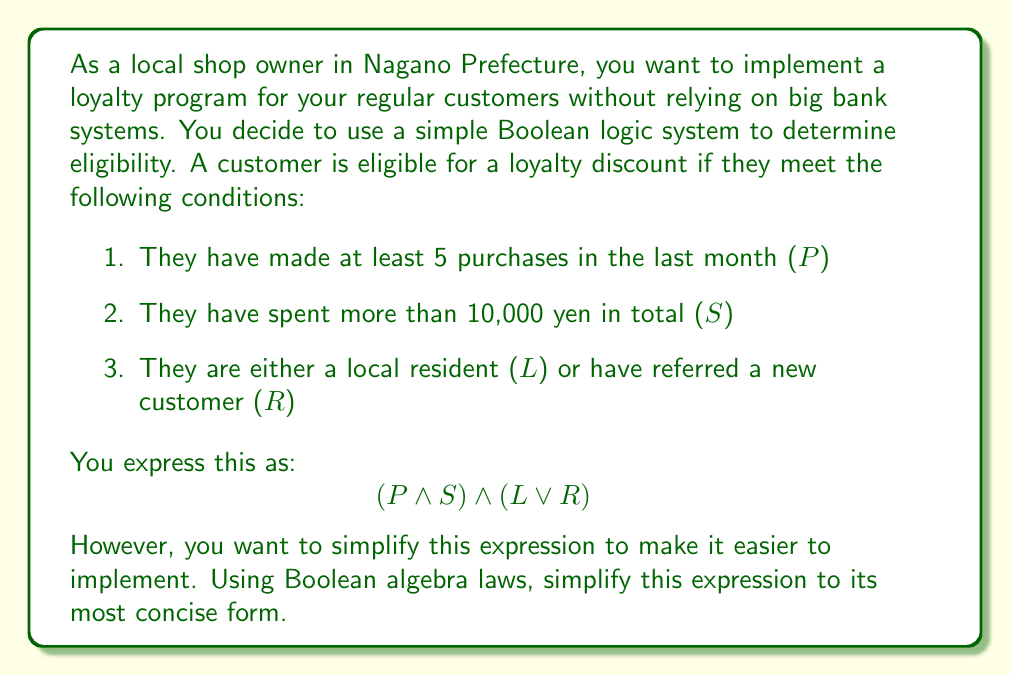Give your solution to this math problem. Let's simplify the expression $$(P \land S) \land (L \lor R)$$ step by step:

1. First, we can apply the associative law of conjunction (AND):
   $$(P \land S) \land (L \lor R) = P \land S \land (L \lor R)$$

2. Now, we can apply the distributive law of conjunction over disjunction:
   $$P \land S \land (L \lor R) = (P \land S \land L) \lor (P \land S \land R)$$

3. At this point, we can't simplify further without losing information. The expression $(P \land S \land L) \lor (P \land S \land R)$ represents two possible ways to be eligible for the loyalty discount:
   - Either the customer has made at least 5 purchases (P) AND spent more than 10,000 yen (S) AND is a local resident (L)
   - OR the customer has made at least 5 purchases (P) AND spent more than 10,000 yen (S) AND has referred a new customer (R)

This simplified form clearly shows the two paths to eligibility, making it easier for you, as a local shop owner, to implement and explain to your customers without relying on complex banking systems.
Answer: $$(P \land S \land L) \lor (P \land S \land R)$$ 